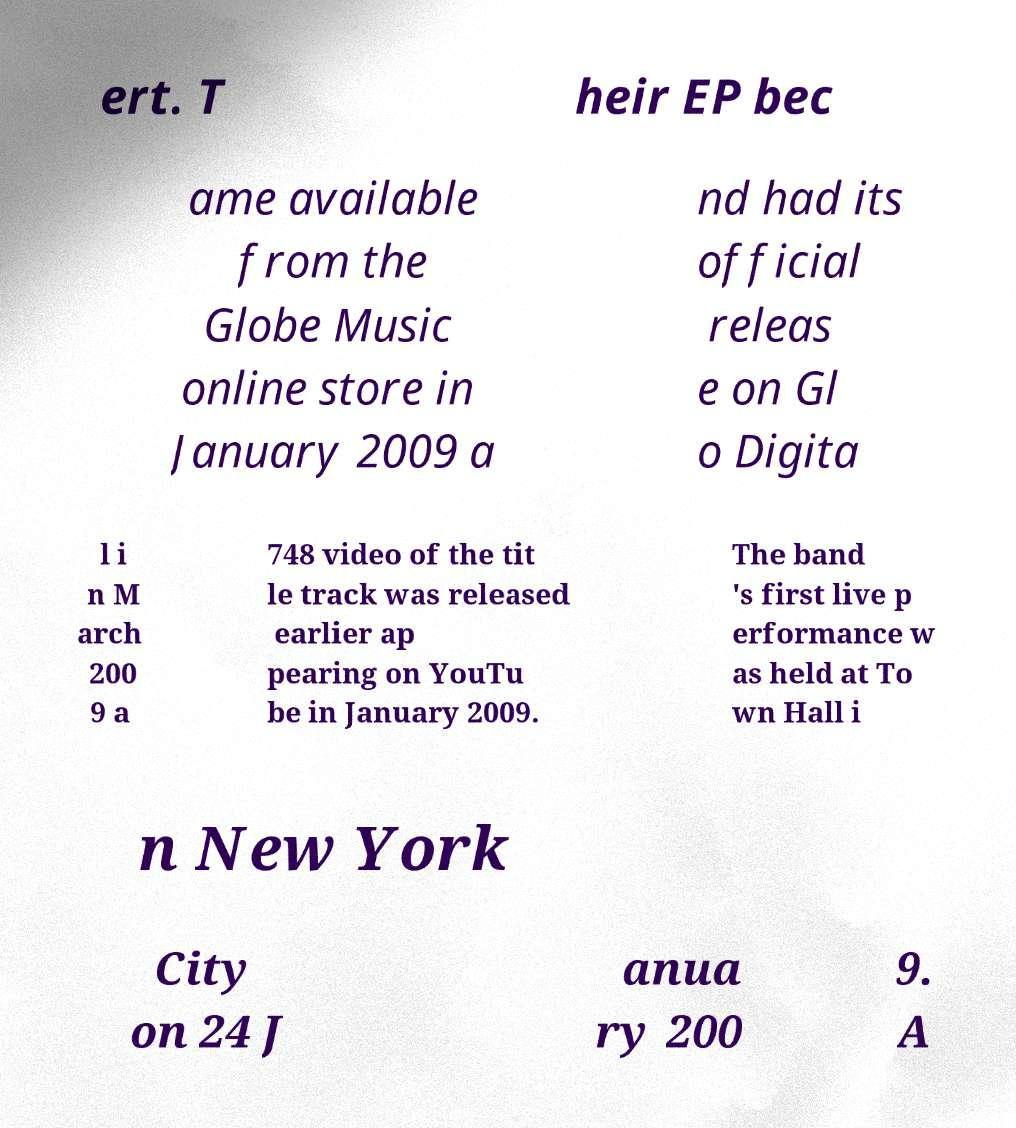There's text embedded in this image that I need extracted. Can you transcribe it verbatim? ert. T heir EP bec ame available from the Globe Music online store in January 2009 a nd had its official releas e on Gl o Digita l i n M arch 200 9 a 748 video of the tit le track was released earlier ap pearing on YouTu be in January 2009. The band 's first live p erformance w as held at To wn Hall i n New York City on 24 J anua ry 200 9. A 